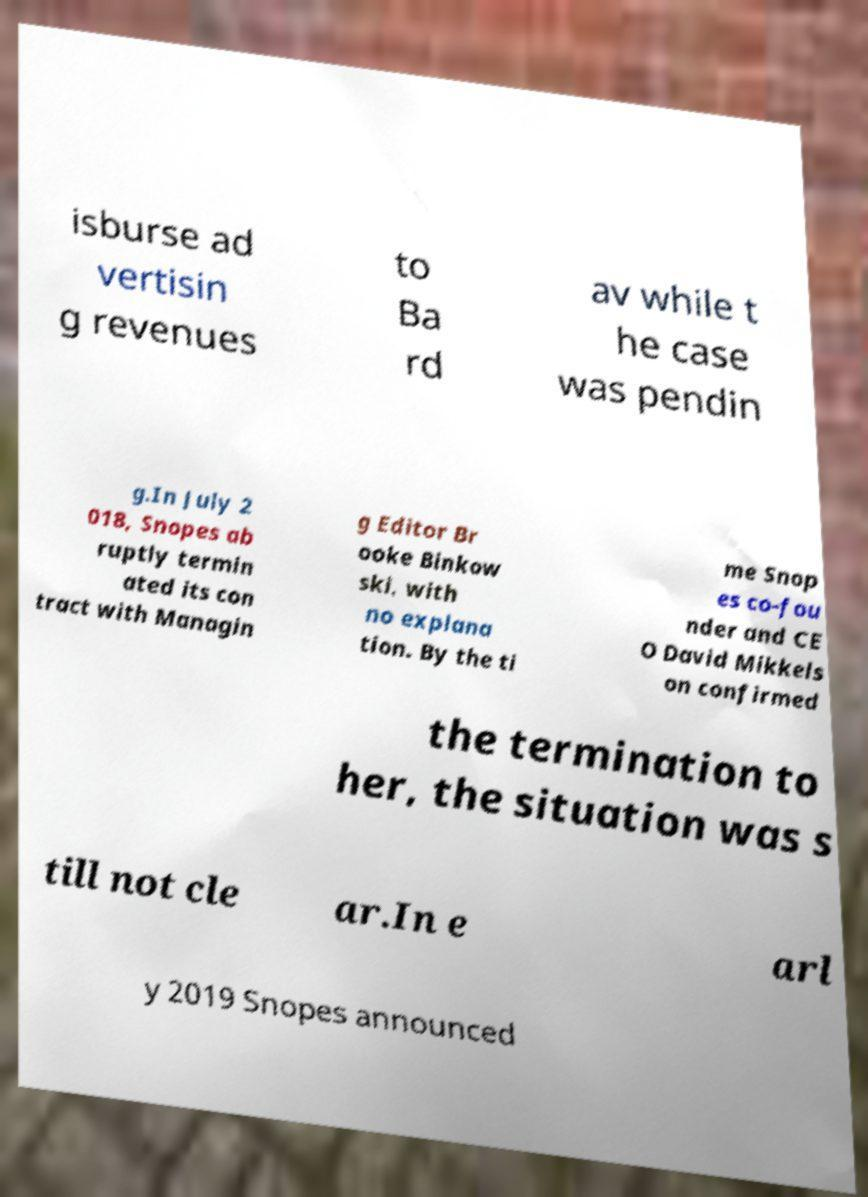Can you accurately transcribe the text from the provided image for me? isburse ad vertisin g revenues to Ba rd av while t he case was pendin g.In July 2 018, Snopes ab ruptly termin ated its con tract with Managin g Editor Br ooke Binkow ski, with no explana tion. By the ti me Snop es co-fou nder and CE O David Mikkels on confirmed the termination to her, the situation was s till not cle ar.In e arl y 2019 Snopes announced 